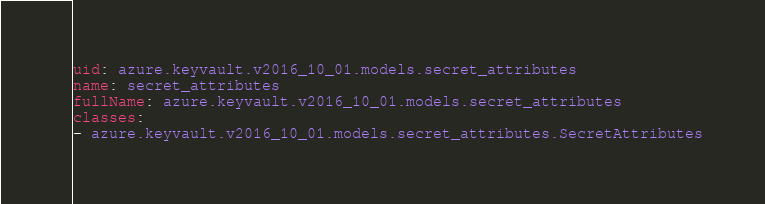Convert code to text. <code><loc_0><loc_0><loc_500><loc_500><_YAML_>uid: azure.keyvault.v2016_10_01.models.secret_attributes
name: secret_attributes
fullName: azure.keyvault.v2016_10_01.models.secret_attributes
classes:
- azure.keyvault.v2016_10_01.models.secret_attributes.SecretAttributes
</code> 